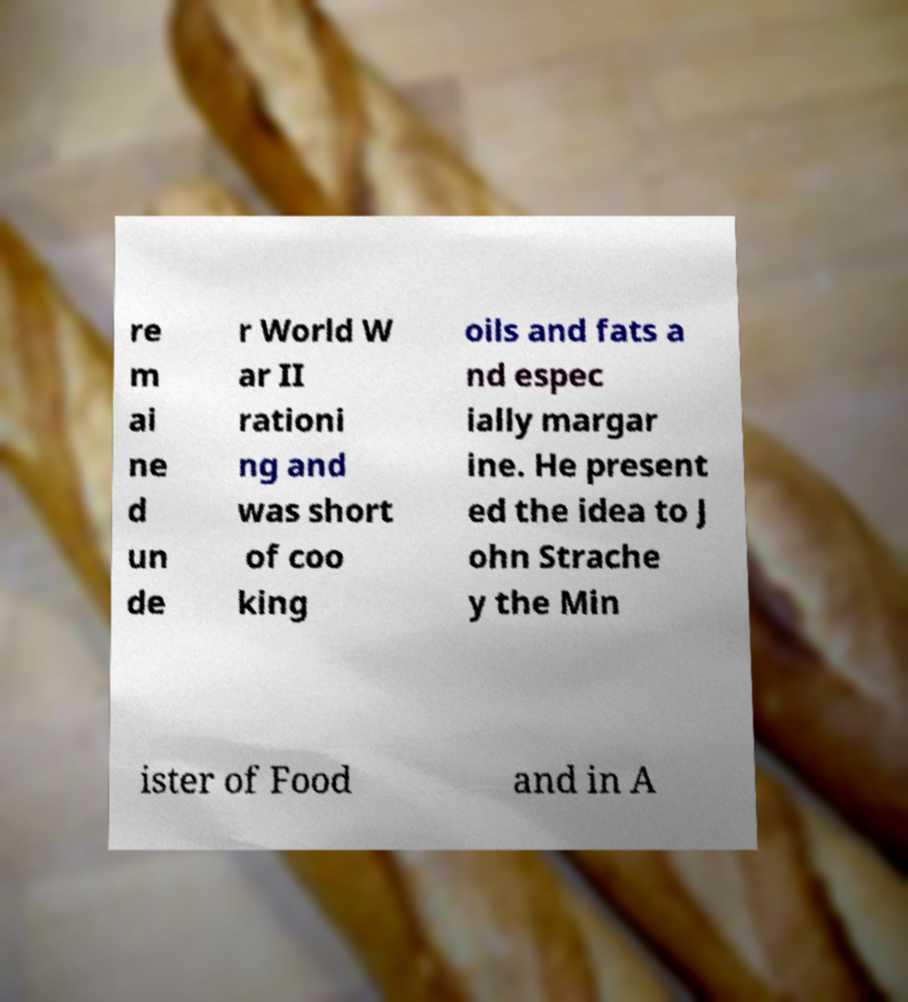Please read and relay the text visible in this image. What does it say? re m ai ne d un de r World W ar II rationi ng and was short of coo king oils and fats a nd espec ially margar ine. He present ed the idea to J ohn Strache y the Min ister of Food and in A 